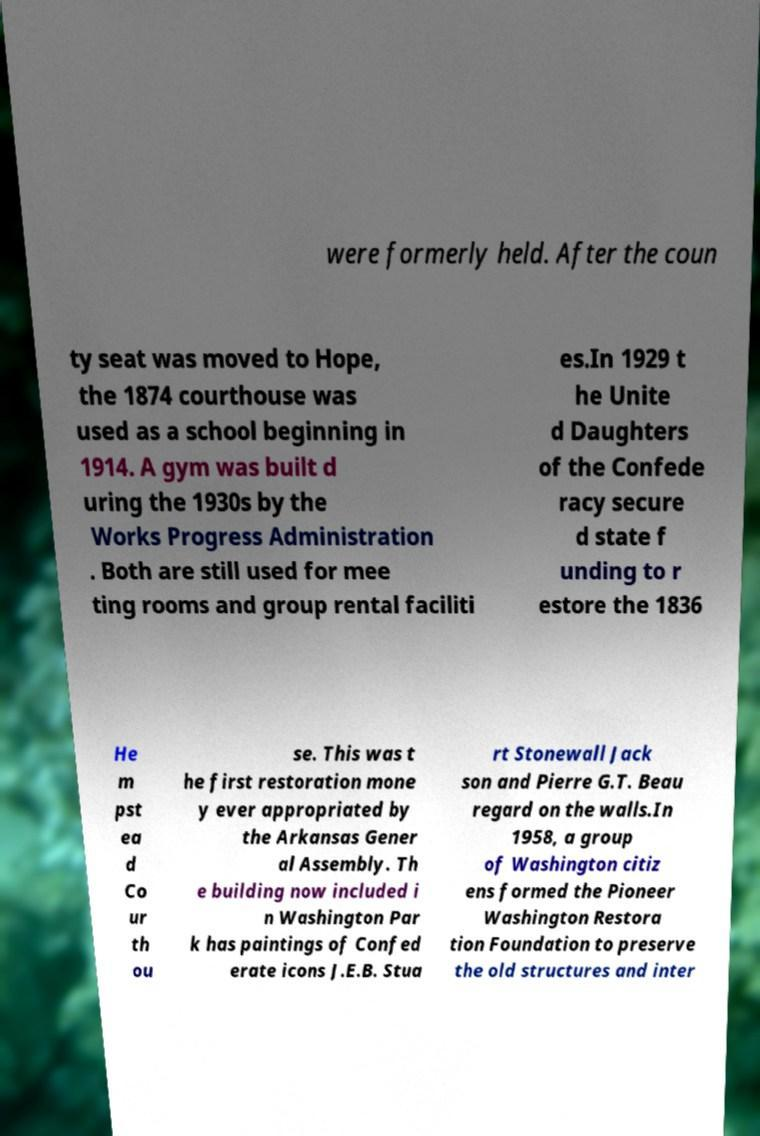For documentation purposes, I need the text within this image transcribed. Could you provide that? were formerly held. After the coun ty seat was moved to Hope, the 1874 courthouse was used as a school beginning in 1914. A gym was built d uring the 1930s by the Works Progress Administration . Both are still used for mee ting rooms and group rental faciliti es.In 1929 t he Unite d Daughters of the Confede racy secure d state f unding to r estore the 1836 He m pst ea d Co ur th ou se. This was t he first restoration mone y ever appropriated by the Arkansas Gener al Assembly. Th e building now included i n Washington Par k has paintings of Confed erate icons J.E.B. Stua rt Stonewall Jack son and Pierre G.T. Beau regard on the walls.In 1958, a group of Washington citiz ens formed the Pioneer Washington Restora tion Foundation to preserve the old structures and inter 